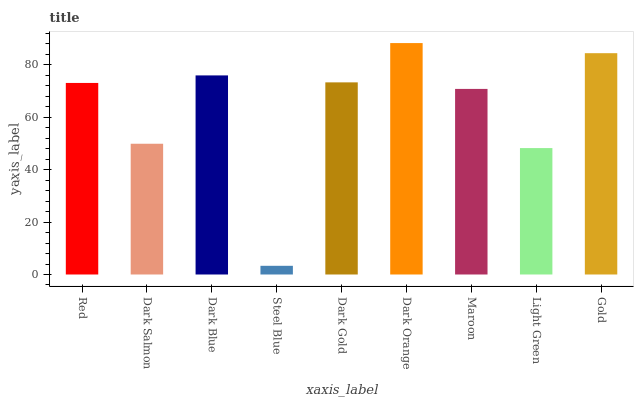Is Steel Blue the minimum?
Answer yes or no. Yes. Is Dark Orange the maximum?
Answer yes or no. Yes. Is Dark Salmon the minimum?
Answer yes or no. No. Is Dark Salmon the maximum?
Answer yes or no. No. Is Red greater than Dark Salmon?
Answer yes or no. Yes. Is Dark Salmon less than Red?
Answer yes or no. Yes. Is Dark Salmon greater than Red?
Answer yes or no. No. Is Red less than Dark Salmon?
Answer yes or no. No. Is Red the high median?
Answer yes or no. Yes. Is Red the low median?
Answer yes or no. Yes. Is Dark Gold the high median?
Answer yes or no. No. Is Dark Orange the low median?
Answer yes or no. No. 